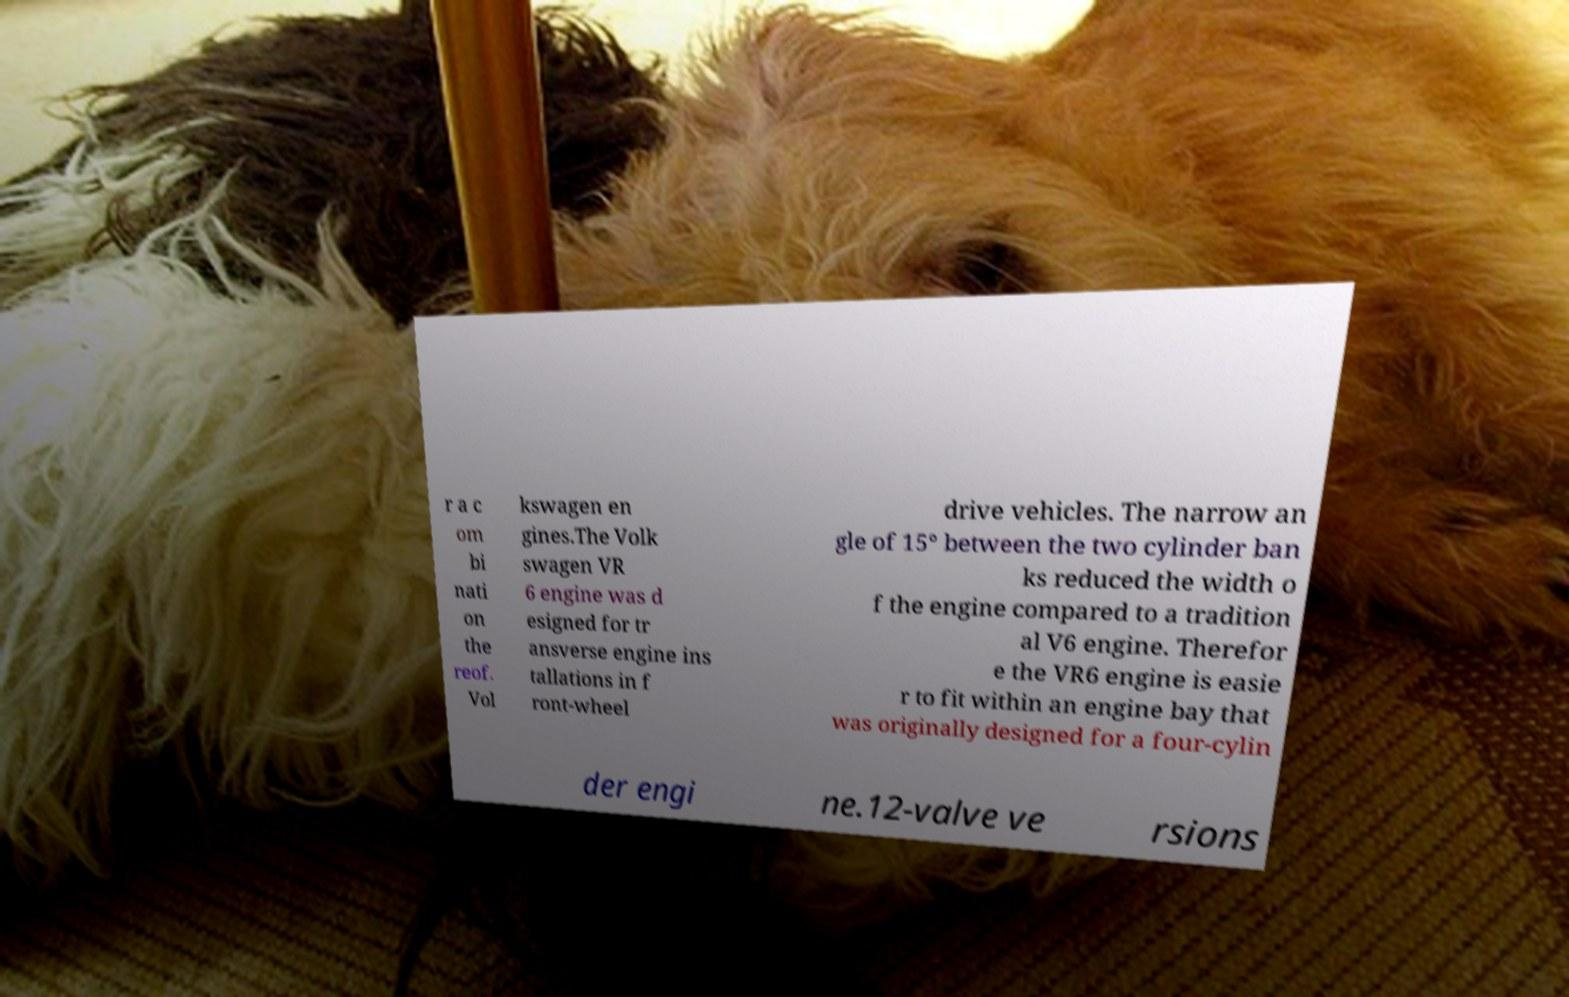Could you assist in decoding the text presented in this image and type it out clearly? r a c om bi nati on the reof. Vol kswagen en gines.The Volk swagen VR 6 engine was d esigned for tr ansverse engine ins tallations in f ront-wheel drive vehicles. The narrow an gle of 15° between the two cylinder ban ks reduced the width o f the engine compared to a tradition al V6 engine. Therefor e the VR6 engine is easie r to fit within an engine bay that was originally designed for a four-cylin der engi ne.12-valve ve rsions 